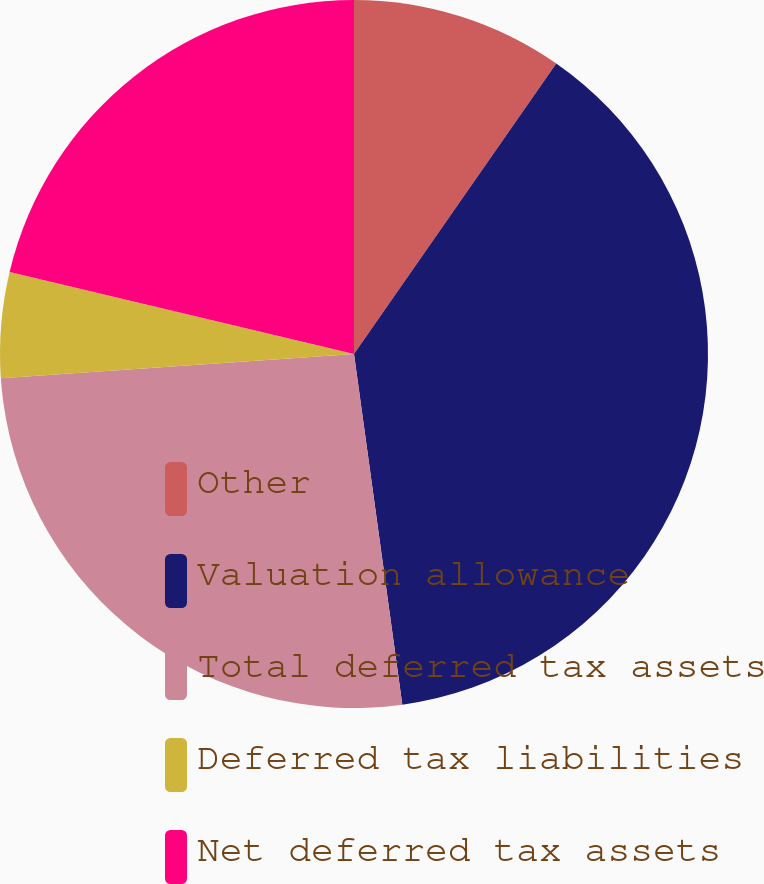Convert chart. <chart><loc_0><loc_0><loc_500><loc_500><pie_chart><fcel>Other<fcel>Valuation allowance<fcel>Total deferred tax assets<fcel>Deferred tax liabilities<fcel>Net deferred tax assets<nl><fcel>9.68%<fcel>38.14%<fcel>26.09%<fcel>4.81%<fcel>21.28%<nl></chart> 